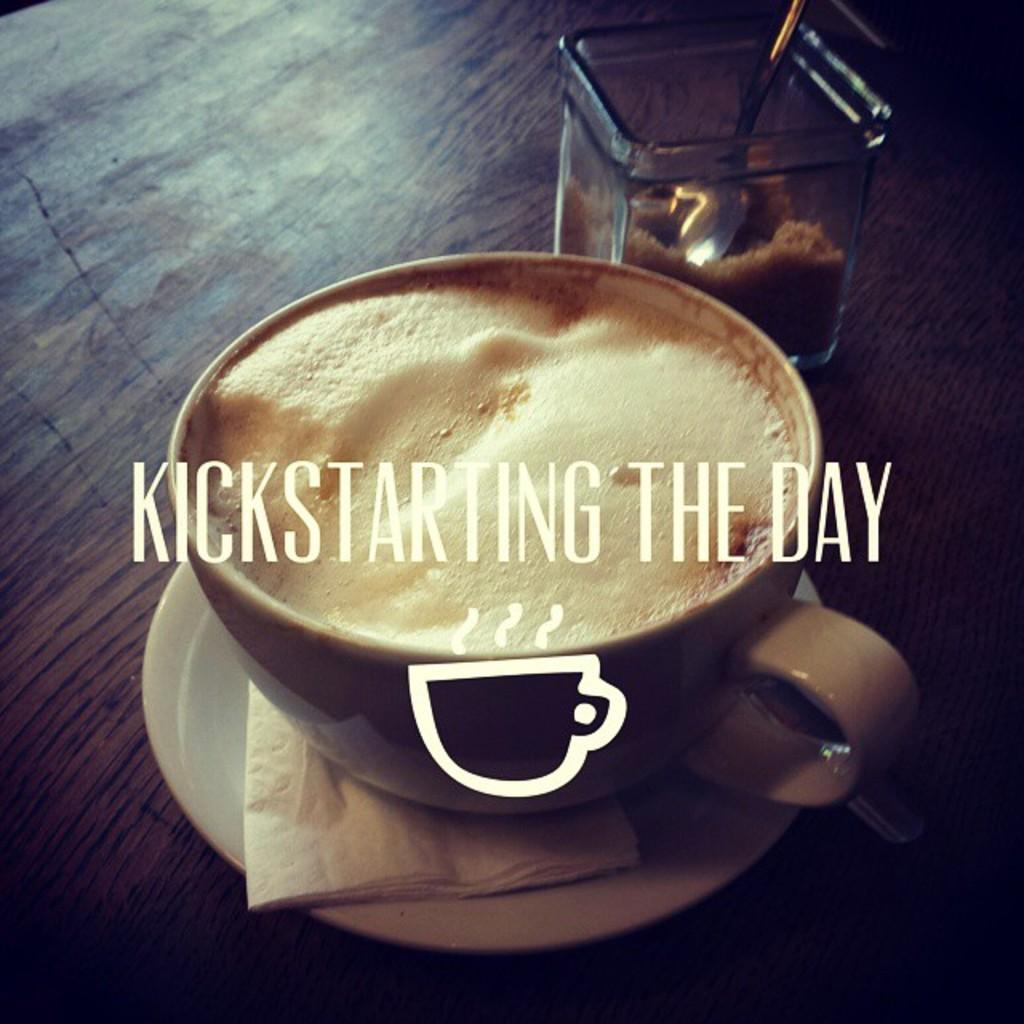What type of dishware is present in the image? There is a coffee cup and saucer in the image. What other item can be seen in the image? There is a tissue in the image. What container is visible in the image? There is a glass jar in the image. What utensil is present in the image? There is a spoon in the image. What material is the surface on which the objects are placed? The objects are on a wooden surface. Where is the rabbit hiding in the image? There is no rabbit present in the image. What type of toothpaste is in the glass jar? There is no toothpaste in the image; it contains a different substance or item. 